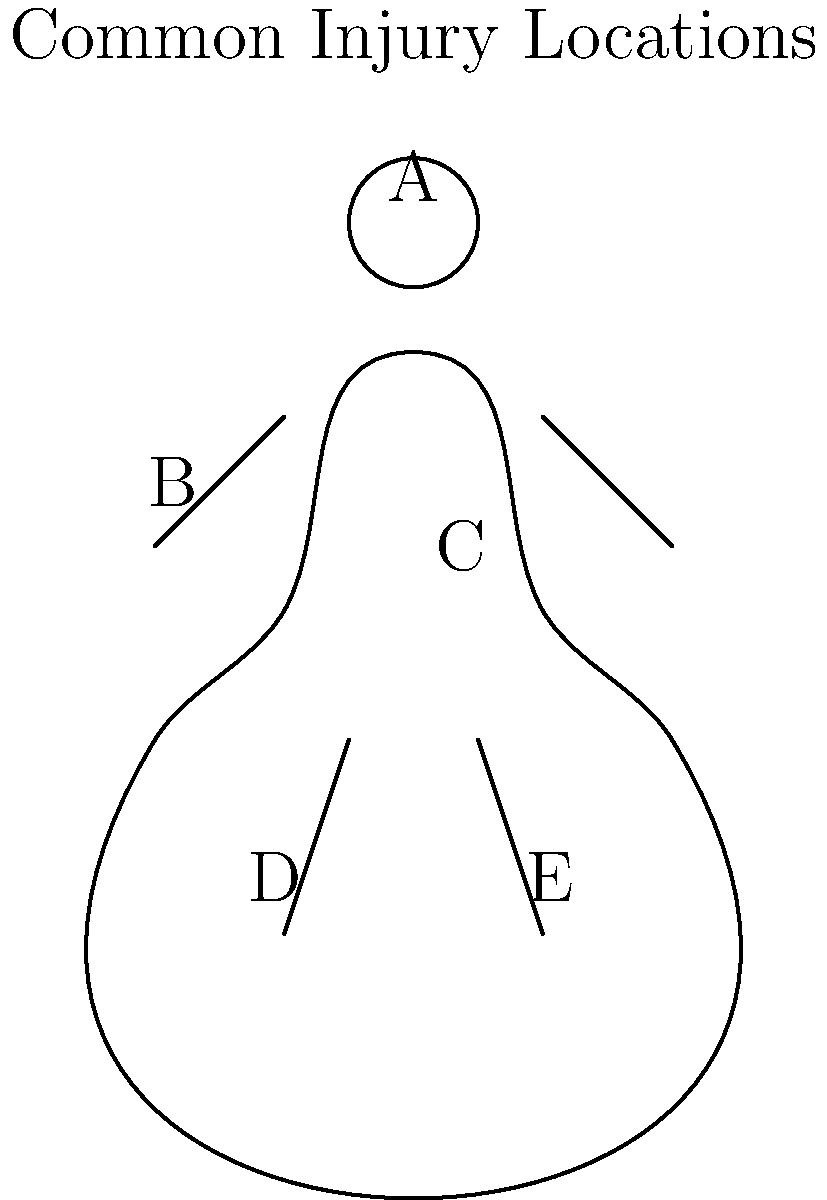Based on the human body diagram provided, which location is most likely to represent the highest percentage of injuries seen in military personnel at your rehabilitation center? To answer this question, we need to consider the common types of injuries sustained by military personnel and their prevalence:

1. Location A (Head): While head injuries can be severe, they are less common due to protective gear.

2. Location B (Shoulder/Upper Arm): Shoulder injuries are common due to heavy lifting and repetitive motions, but not the most prevalent.

3. Location C (Lower Back): Lower back injuries are extremely common in military personnel due to:
   - Carrying heavy equipment and gear for extended periods
   - Repetitive lifting and loading tasks
   - Prolonged periods in vehicles with poor ergonomics
   - High-impact activities like parachuting or combat maneuvers

4. Location D (Knee): Knee injuries are also common, but typically less frequent than lower back injuries.

5. Location E (Ankle/Foot): While ankle and foot injuries occur, they are generally less prevalent than lower back issues.

Given these considerations, Location C (Lower Back) is most likely to represent the highest percentage of injuries seen in military personnel at a rehabilitation center. Lower back injuries are pervasive due to the nature of military activities and often require extensive rehabilitation.
Answer: C (Lower Back) 